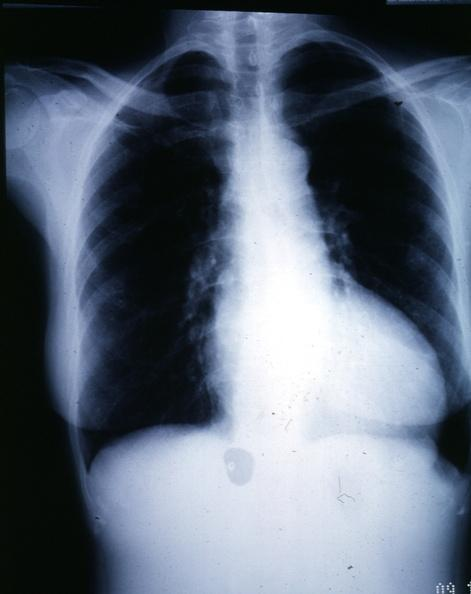s cardiovascular present?
Answer the question using a single word or phrase. Yes 